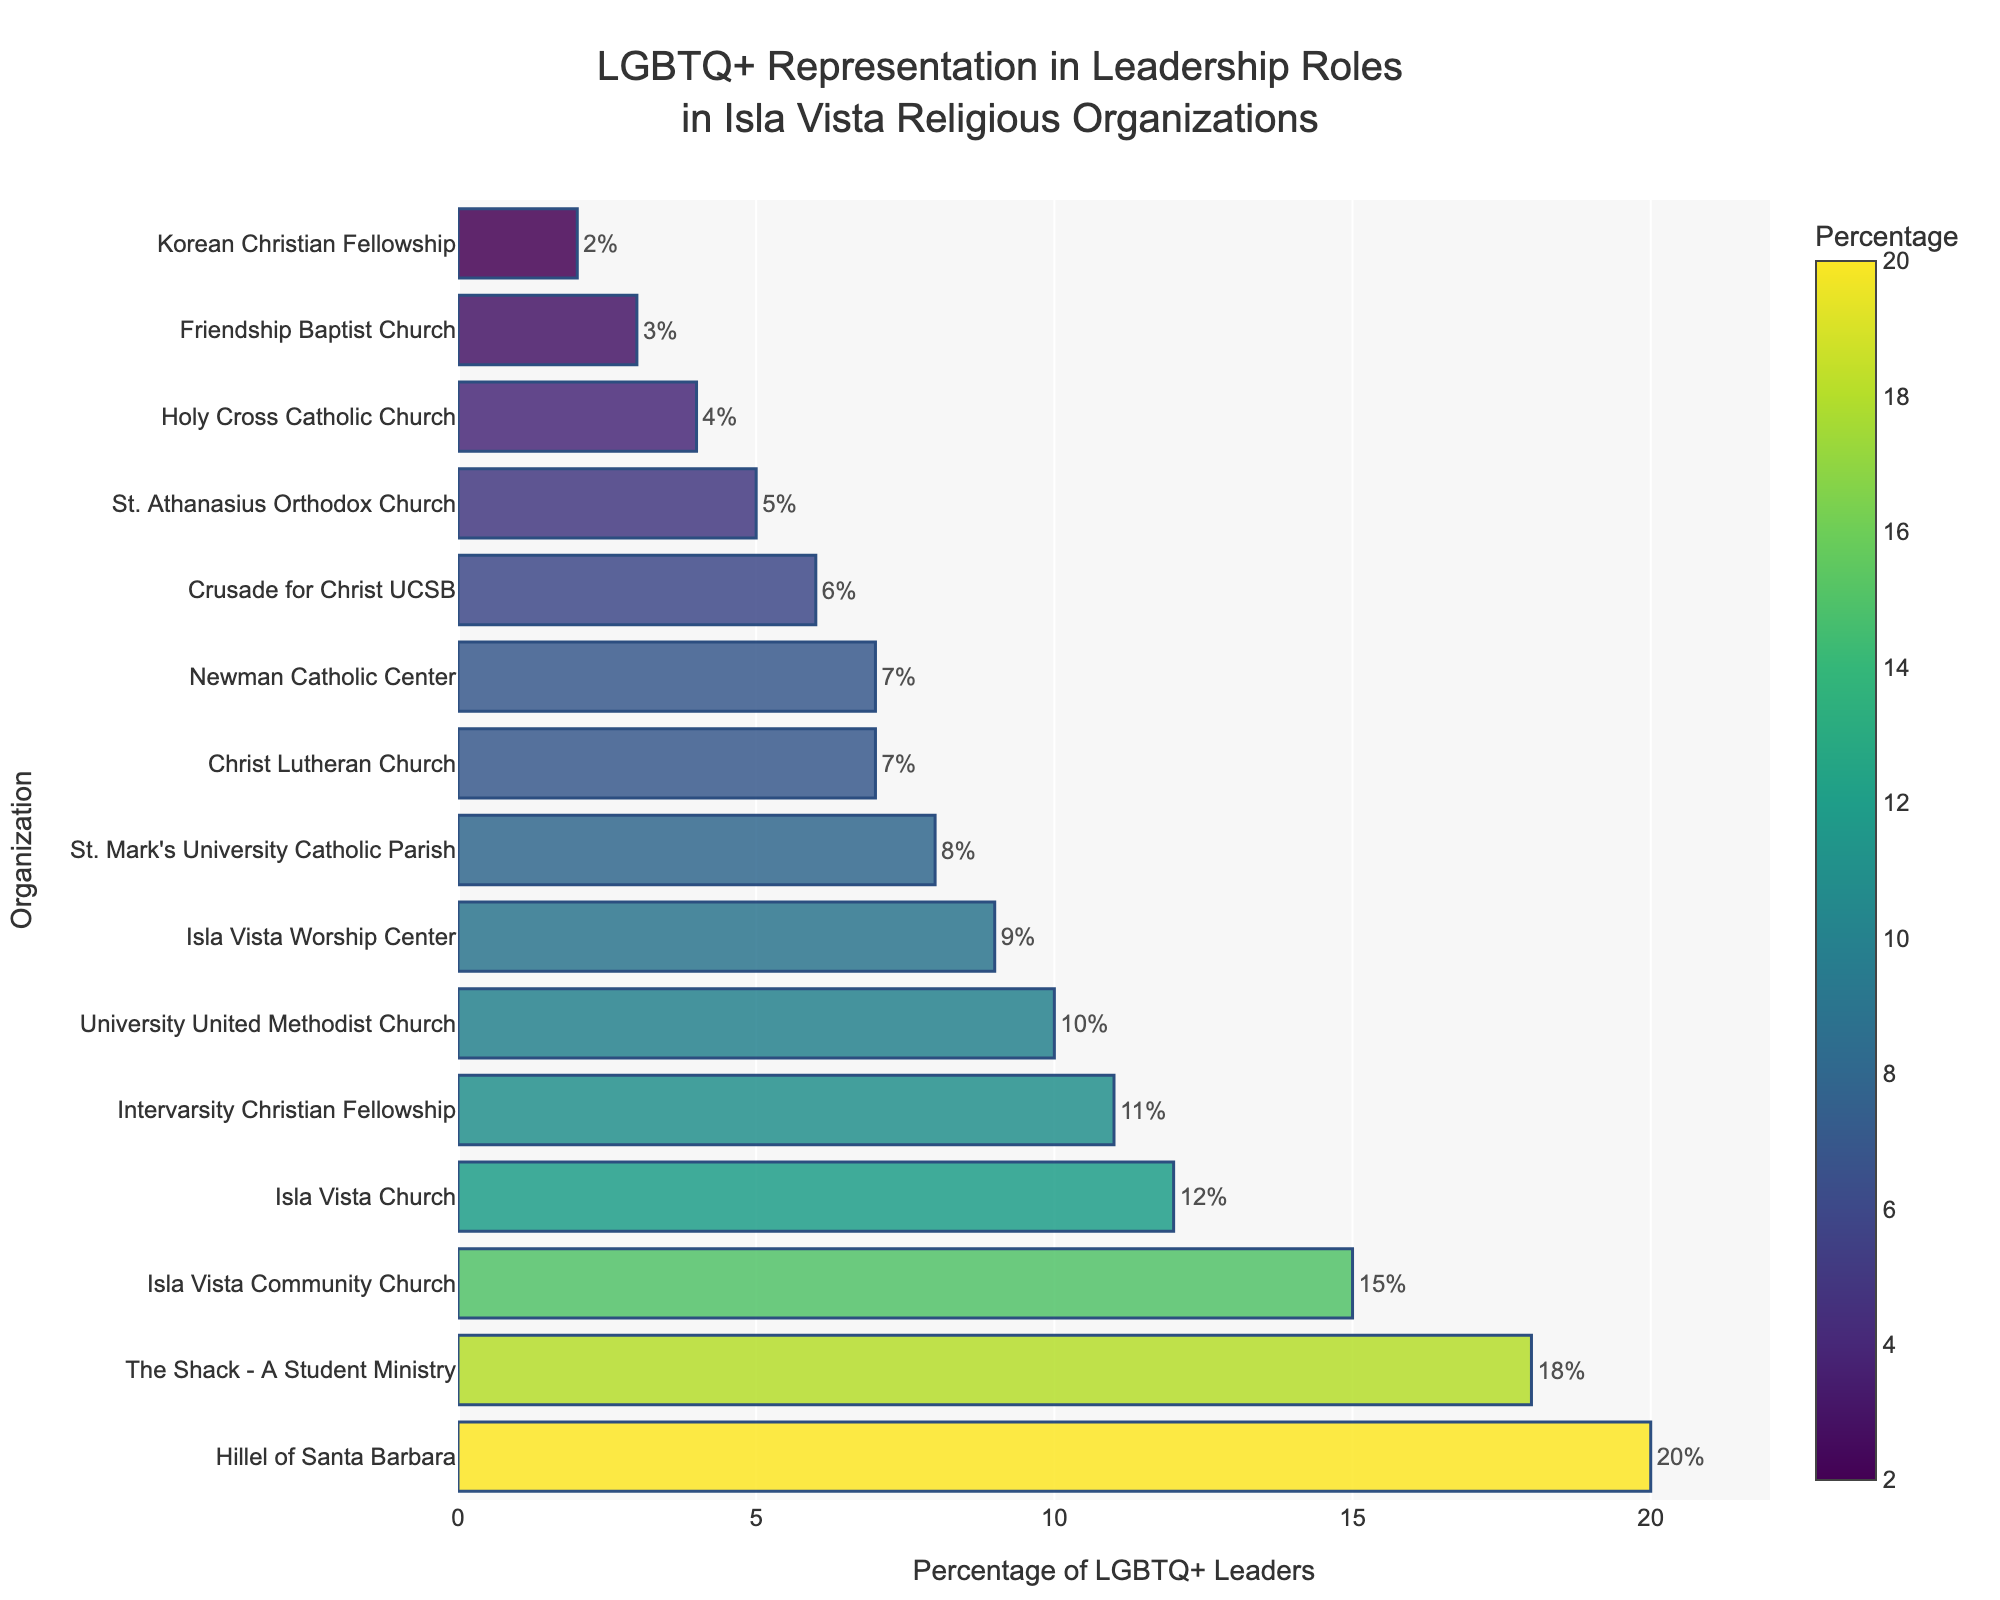Which organization has the highest percentage of LGBTQ+ leaders? The bar chart shows the percentage of LGBTQ+ leaders for each organization. Hillel of Santa Barbara has the longest bar, indicating the highest percentage.
Answer: Hillel of Santa Barbara What is the percentage difference between the organization with the most LGBTQ+ leaders and the one with the least? Hillel of Santa Barbara has the highest percentage at 20%, and Korean Christian Fellowship has the lowest at 2%. The difference is 20% - 2% = 18%.
Answer: 18% Which organizations have LGBTQ+ leaders representing 10% or more of their leadership? The bars representing The Shack - A Student Ministry (18%), Isla Vista Community Church (15%), Isla Vista Church (12%), Intervarsity Christian Fellowship (11%), University United Methodist Church (10%), and Hillel of Santa Barbara (20%) are above the 10% mark.
Answer: The Shack - A Student Ministry, Isla Vista Community Church, Isla Vista Church, Intervarsity Christian Fellowship, University United Methodist Church, Hillel of Santa Barbara How much higher is the percentage of LGBTQ+ leaders in The Shack - A Student Ministry compared to St. Athanasius Orthodox Church? The Shack - A Student Ministry has 18% while St. Athanasius Orthodox Church has 5%. The difference is 18% - 5% = 13%.
Answer: 13% What is the average percentage of LGBTQ+ leaders among all organizations? To find the average, sum up all percentages and divide by the number of organizations: (12% + 5% + 8% + 15% + 3% + 7% + 18% + 10% + 20% + 4% + 9% + 6% + 2% + 11% + 7%) / 15 = 137% / 15 = 9.13%.
Answer: 9.13% Which organization has the closest percentage of LGBTQ+ leaders to Isla Vista Worship Center? Isla Vista Worship Center has 9% LGBTQ+ leaders. University United Methodist Church has 10%, and St. Mark's University Catholic Parish has 8%. Both are close, but St. Mark's University Catholic Parish is closer by a margin of 1%.
Answer: St. Mark's University Catholic Parish What is the total percentage of LGBTQ+ leaders if you combine the top three organizations? The top three organizations are Hillel of Santa Barbara (20%), The Shack - A Student Ministry (18%), and Isla Vista Community Church (15%). The total is 20% + 18% + 15% = 53%.
Answer: 53% Which organizations have less than 5% representation of LGBTQ+ leaders? According to the chart, the organizations with less than 5% are Friendship Baptist Church (3%), Holy Cross Catholic Church (4%), and Korean Christian Fellowship (2%).
Answer: Friendship Baptist Church, Holy Cross Catholic Church, Korean Christian Fellowship How does the percentage of LGBTQ+ leaders in Intervarsity Christian Fellowship compare to that in Newman Catholic Center? Intervarsity Christian Fellowship has 11% while Newman Catholic Center has 7%. Thus, Intervarsity Christian Fellowship has 4% more than Newman Catholic Center.
Answer: 4% more What is the range of percentages represented in the chart? The highest percentage is 20% (Hillel of Santa Barbara) and the lowest is 2% (Korean Christian Fellowship). The range is 20% - 2% = 18%.
Answer: 18% 